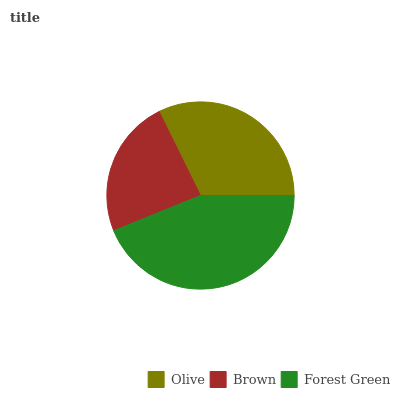Is Brown the minimum?
Answer yes or no. Yes. Is Forest Green the maximum?
Answer yes or no. Yes. Is Forest Green the minimum?
Answer yes or no. No. Is Brown the maximum?
Answer yes or no. No. Is Forest Green greater than Brown?
Answer yes or no. Yes. Is Brown less than Forest Green?
Answer yes or no. Yes. Is Brown greater than Forest Green?
Answer yes or no. No. Is Forest Green less than Brown?
Answer yes or no. No. Is Olive the high median?
Answer yes or no. Yes. Is Olive the low median?
Answer yes or no. Yes. Is Brown the high median?
Answer yes or no. No. Is Forest Green the low median?
Answer yes or no. No. 